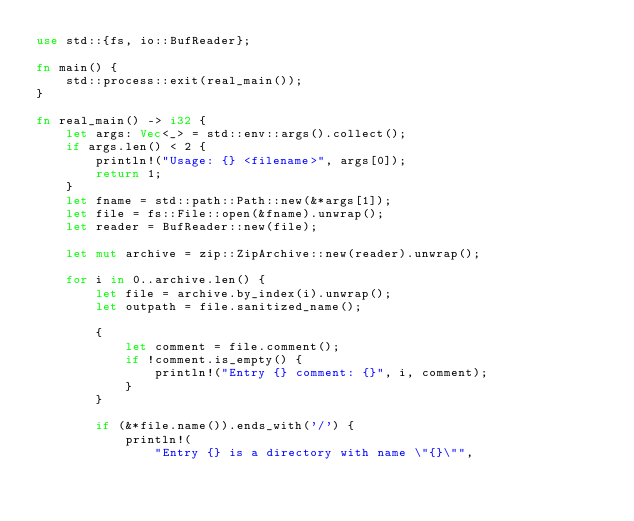Convert code to text. <code><loc_0><loc_0><loc_500><loc_500><_Rust_>use std::{fs, io::BufReader};

fn main() {
    std::process::exit(real_main());
}

fn real_main() -> i32 {
    let args: Vec<_> = std::env::args().collect();
    if args.len() < 2 {
        println!("Usage: {} <filename>", args[0]);
        return 1;
    }
    let fname = std::path::Path::new(&*args[1]);
    let file = fs::File::open(&fname).unwrap();
    let reader = BufReader::new(file);

    let mut archive = zip::ZipArchive::new(reader).unwrap();

    for i in 0..archive.len() {
        let file = archive.by_index(i).unwrap();
        let outpath = file.sanitized_name();

        {
            let comment = file.comment();
            if !comment.is_empty() {
                println!("Entry {} comment: {}", i, comment);
            }
        }

        if (&*file.name()).ends_with('/') {
            println!(
                "Entry {} is a directory with name \"{}\"",</code> 